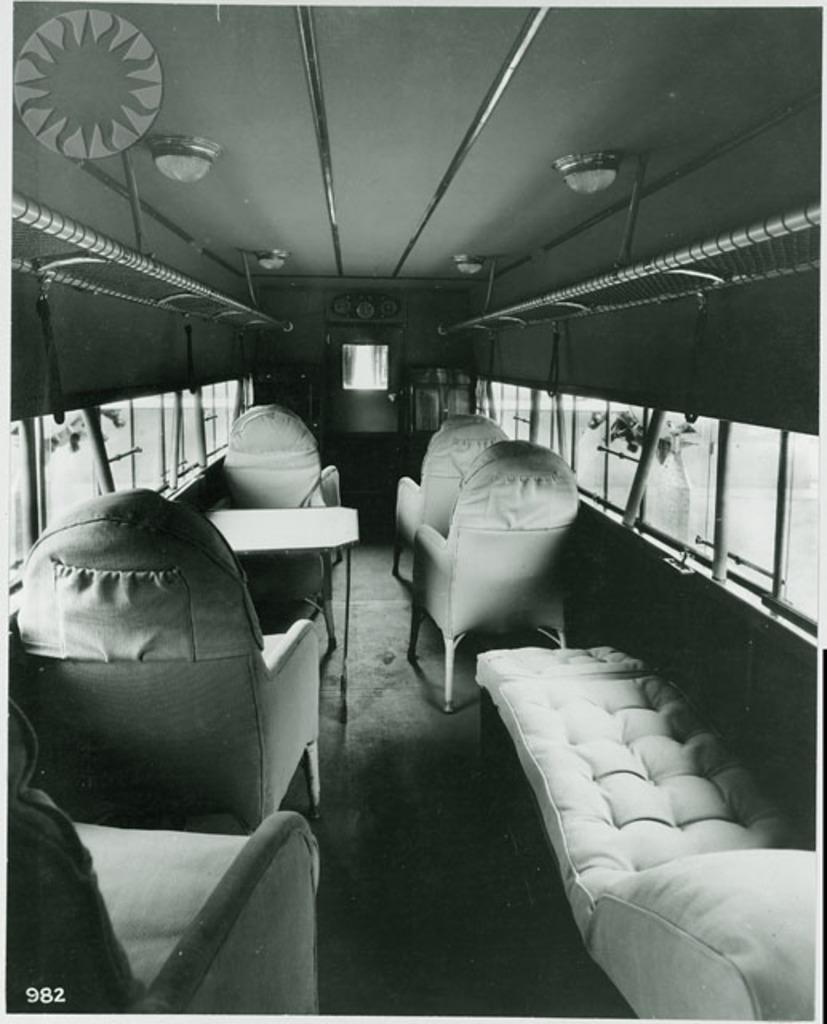Describe this image in one or two sentences. In this image we can see a vehicle, there we can see few chairs, a table, sofa, few window glasses, poles, lights and a tree outside the vehicle. 